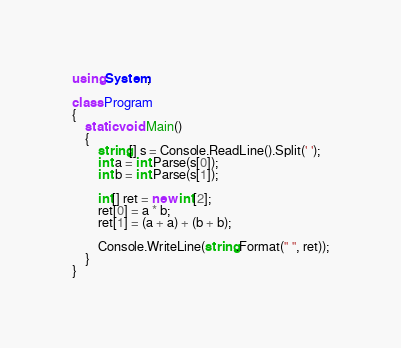Convert code to text. <code><loc_0><loc_0><loc_500><loc_500><_C#_>using System;

class Program
{
    static void Main()
    {
        string[] s = Console.ReadLine().Split(' ');
        int a = int.Parse(s[0]);
        int b = int.Parse(s[1]);

        int[] ret = new int[2];
        ret[0] = a * b;
        ret[1] = (a + a) + (b + b);

        Console.WriteLine(string.Format(" ", ret));
    }
}
</code> 